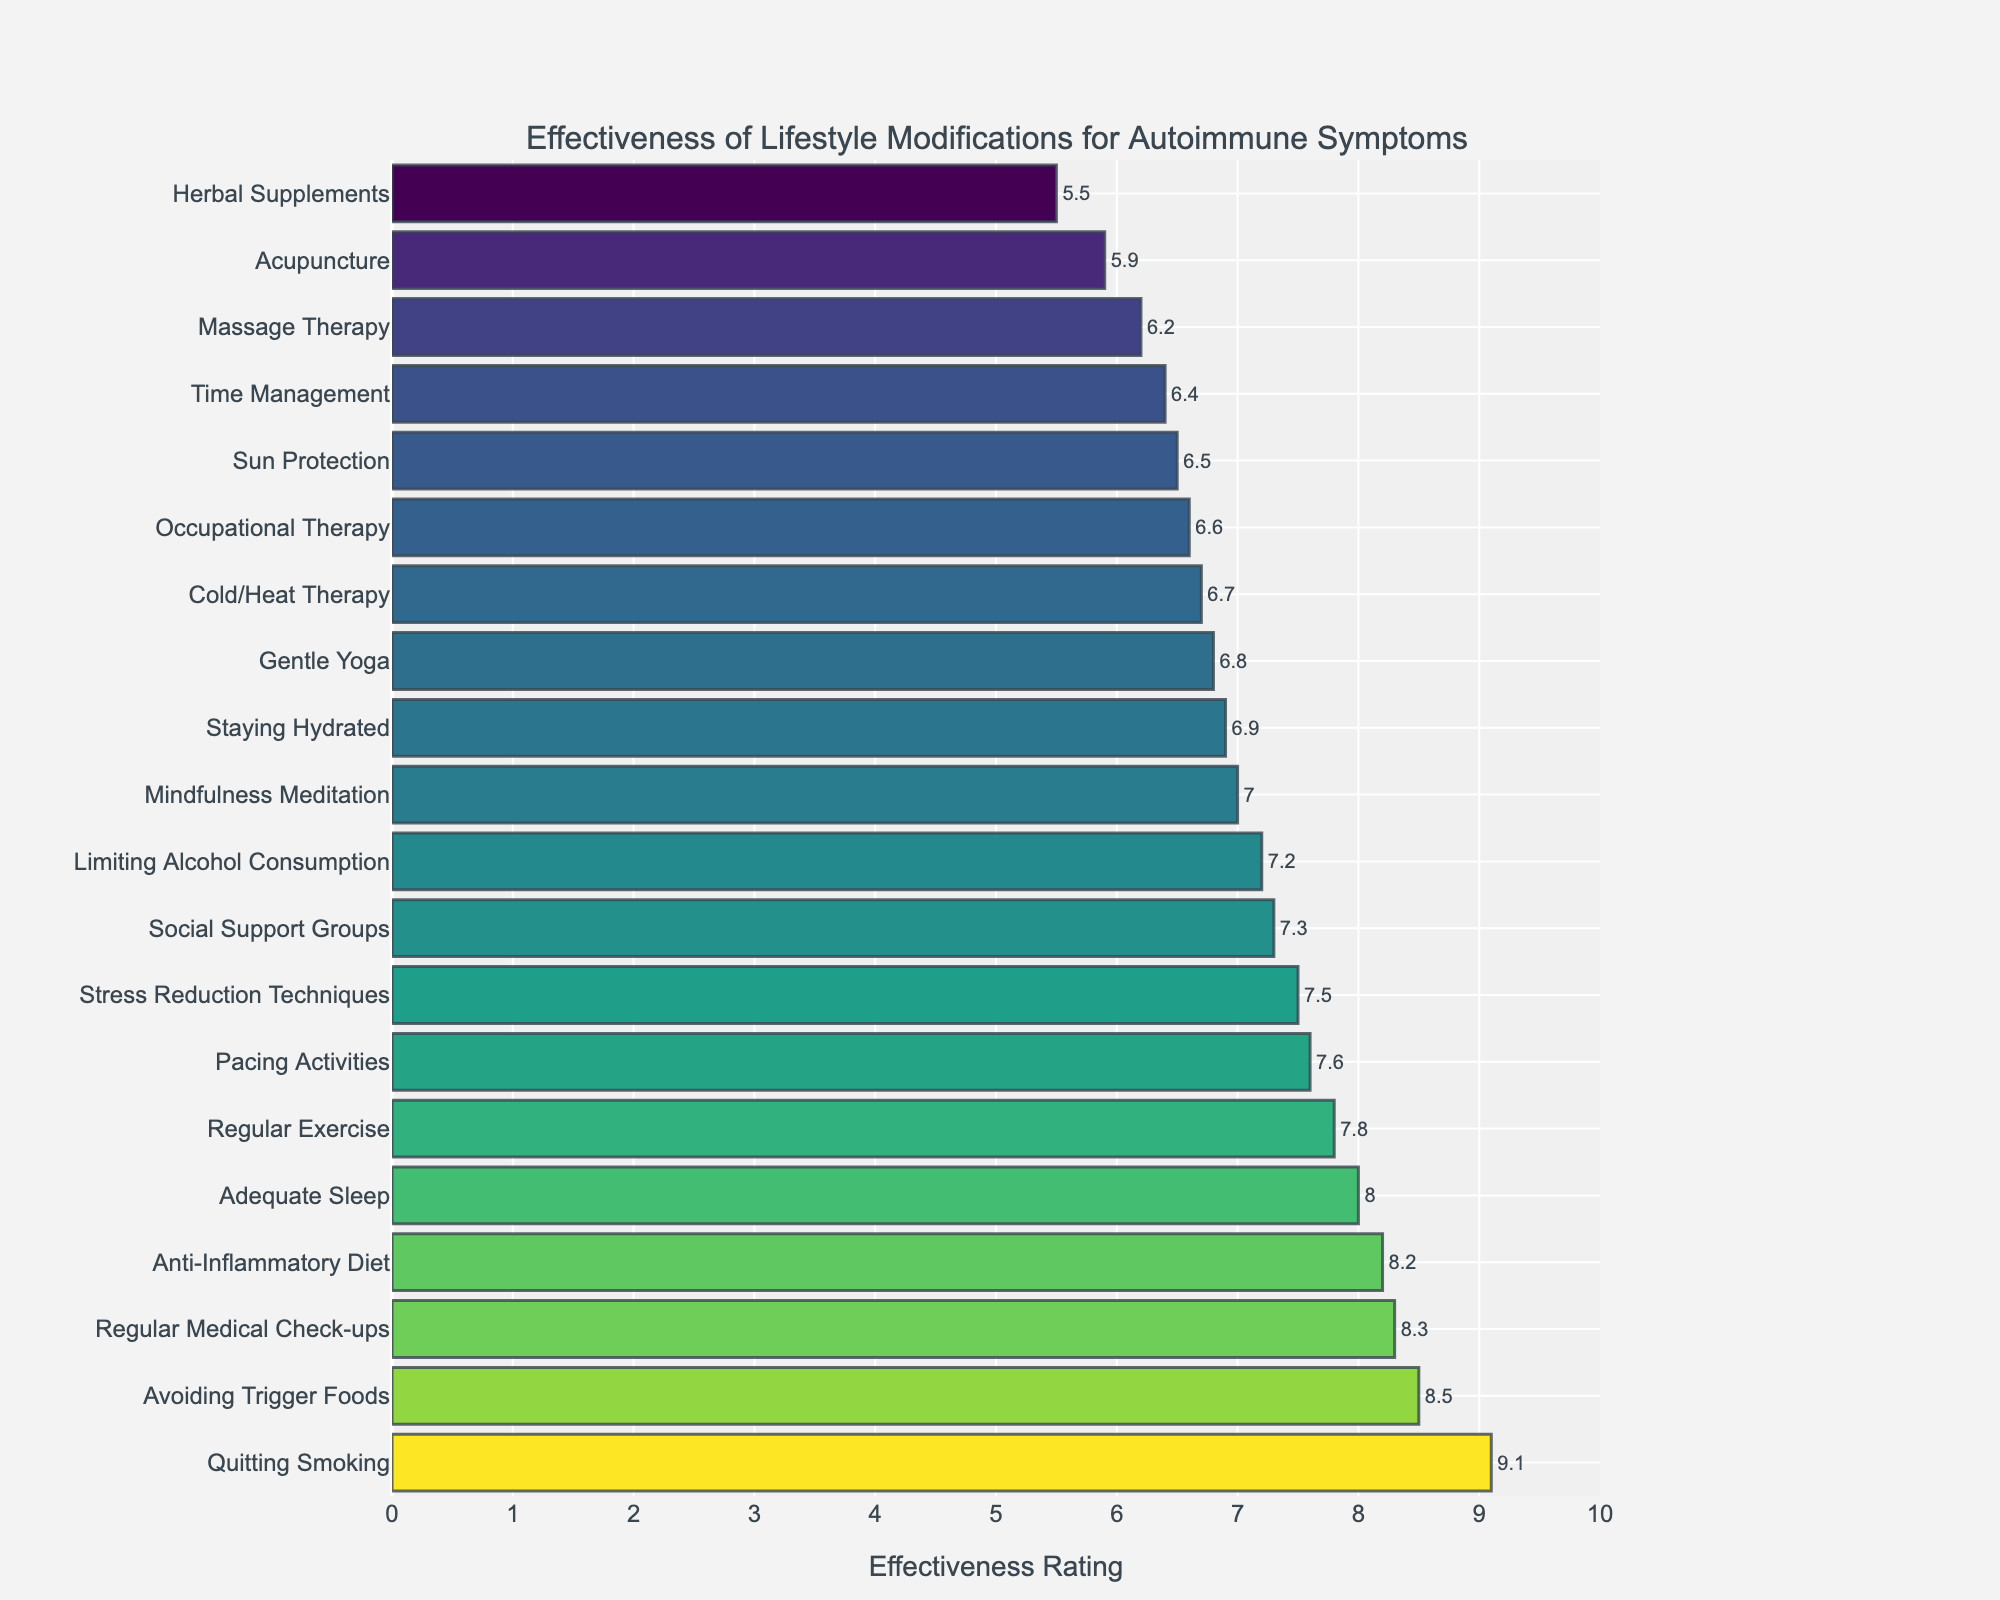Which lifestyle modification has the highest effectiveness rating? Look for the tallest bar in the figure; it will correspond to the highest value.
Answer: Quitting Smoking Which lifestyle modification has the lowest effectiveness rating? Look for the shortest bar in the figure; it will correspond to the lowest value.
Answer: Herbal Supplements How much more effective is Quitting Smoking compared to Acupuncture? Find the effectiveness ratings for Quitting Smoking (9.1) and Acupuncture (5.9) and subtract Acupuncture's rating from Quitting Smoking's rating. 9.1 - 5.9 = 3.2
Answer: 3.2 What is the average effectiveness rating of the top three lifestyle modifications? Identify the top three ratings: 9.1 (Quitting Smoking), 8.5 (Avoiding Trigger Foods), and 8.3 (Regular Medical Check-ups). Calculate their average: (9.1 + 8.5 + 8.3) / 3.
Answer: 8.63 What is the difference in effectiveness between Regular Exercise and Mindfulness Meditation? Find the effectiveness ratings for Regular Exercise (7.8) and Mindfulness Meditation (7.0) and calculate the difference. 7.8 - 7.0 = 0.8
Answer: 0.8 Which lifestyle modification related to diet has the higher effectiveness rating, Anti-Inflammatory Diet or Avoiding Trigger Foods? Compare the effectiveness ratings for Anti-Inflammatory Diet (8.2) and Avoiding Trigger Foods (8.5).
Answer: Avoiding Trigger Foods What is the total effectiveness rating for Stress Reduction Techniques, Staying Hydrated, and Social Support Groups combined? Sum the effectiveness ratings for Stress Reduction Techniques (7.5), Staying Hydrated (6.9), and Social Support Groups (7.3). 7.5 + 6.9 + 7.3 = 21.7
Answer: 21.7 Which lifestyle modifications are rated below 6.0 in effectiveness? Identify all bars with ratings below 6.0.
Answer: Herbal Supplements, Acupuncture Is Adequate Sleep more effective than Pacing Activities? Compare the effectiveness ratings for Adequate Sleep (8.0) and Pacing Activities (7.6).
Answer: Yes How does the effectiveness of Massage Therapy compare to Cold/Heat Therapy? Compare the effectiveness ratings for Massage Therapy (6.2) and Cold/Heat Therapy (6.7).
Answer: Cold/Heat Therapy is more effective 